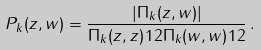Convert formula to latex. <formula><loc_0><loc_0><loc_500><loc_500>P _ { k } ( z , w ) = \frac { | \Pi _ { k } ( z , w ) | } { \Pi _ { k } ( z , z ) ^ { } { 1 } 2 \Pi _ { k } ( w , w ) ^ { } { 1 } 2 } \, .</formula> 